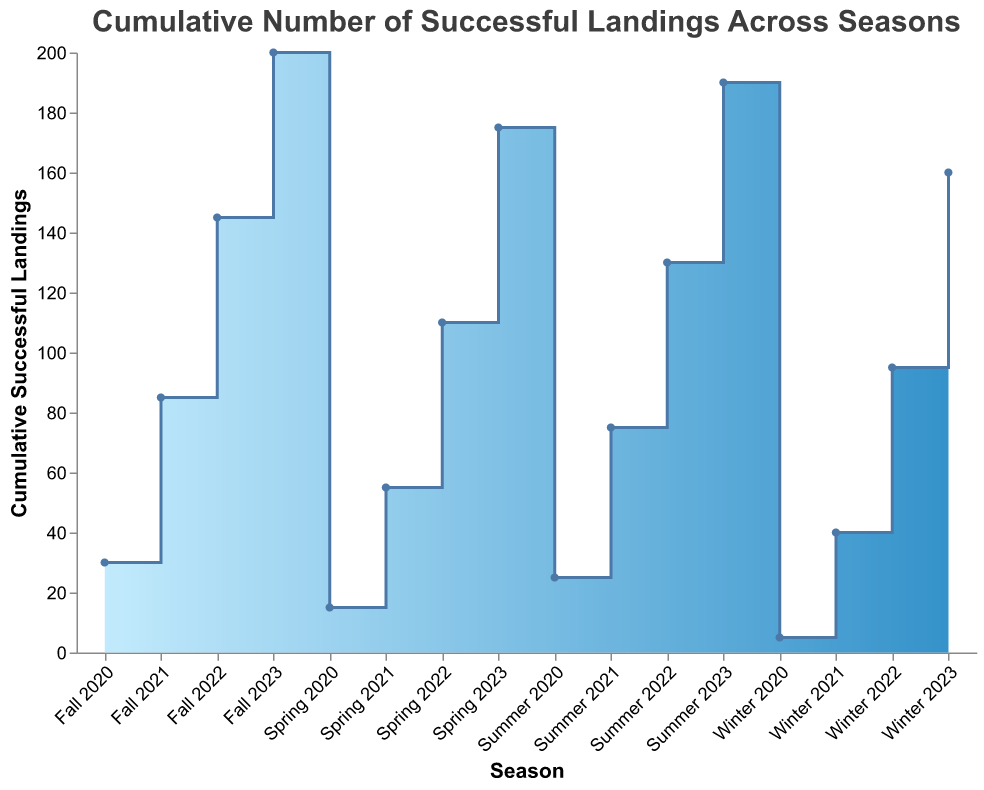How many successful landings were there in Fall 2021? Look at the data point for Fall 2021 in the chart.
Answer: 85 What is the cumulative number of successful landings by Winter 2022? Check the data point corresponding to Winter 2022.
Answer: 95 In which season did the number of successful landings first exceed 50? Identify the season that crosses 50 on the y-axis first.
Answer: Spring 2021 What season saw the highest increase in the number of successful landings? Determine the season with the largest vertical step between two successive points.
Answer: Summer 2021 What is the difference in the number of successful landings between Summer 2022 and Fall 2022? Subtract the number at Summer 2022 from the number at Fall 2022 (145 - 130).
Answer: 15 Which season experienced the least growth compared to the previous season? Compare the vertical steps between each pair of consecutive seasons to find the smallest increment.
Answer: Fall 2020 How many cumulative successful landings were recorded by the end of 2020? Sum the numbers up till Fall 2020. The cumulative record is shown for Fall 2020.
Answer: 30 Between which two consecutive seasons was the increase in successful landings exactly 20? Find pairs where the difference in the number of successful landings between two consecutive seasons is 20.
Answer: Summer 2021 to Winter 2022 By how much does the cumulative number of successful landings increase from Winter 2021 to Summer 2021? Subtract the number at Winter 2021 from the number at Summer 2021 (75 - 40).
Answer: 35 How many steps are there in total on the Step Area Chart? Count the number of vertical segments on the line.
Answer: 16 